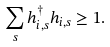<formula> <loc_0><loc_0><loc_500><loc_500>\sum _ { s } h ^ { \dag } _ { i , s } h _ { i , s } \geq 1 .</formula> 